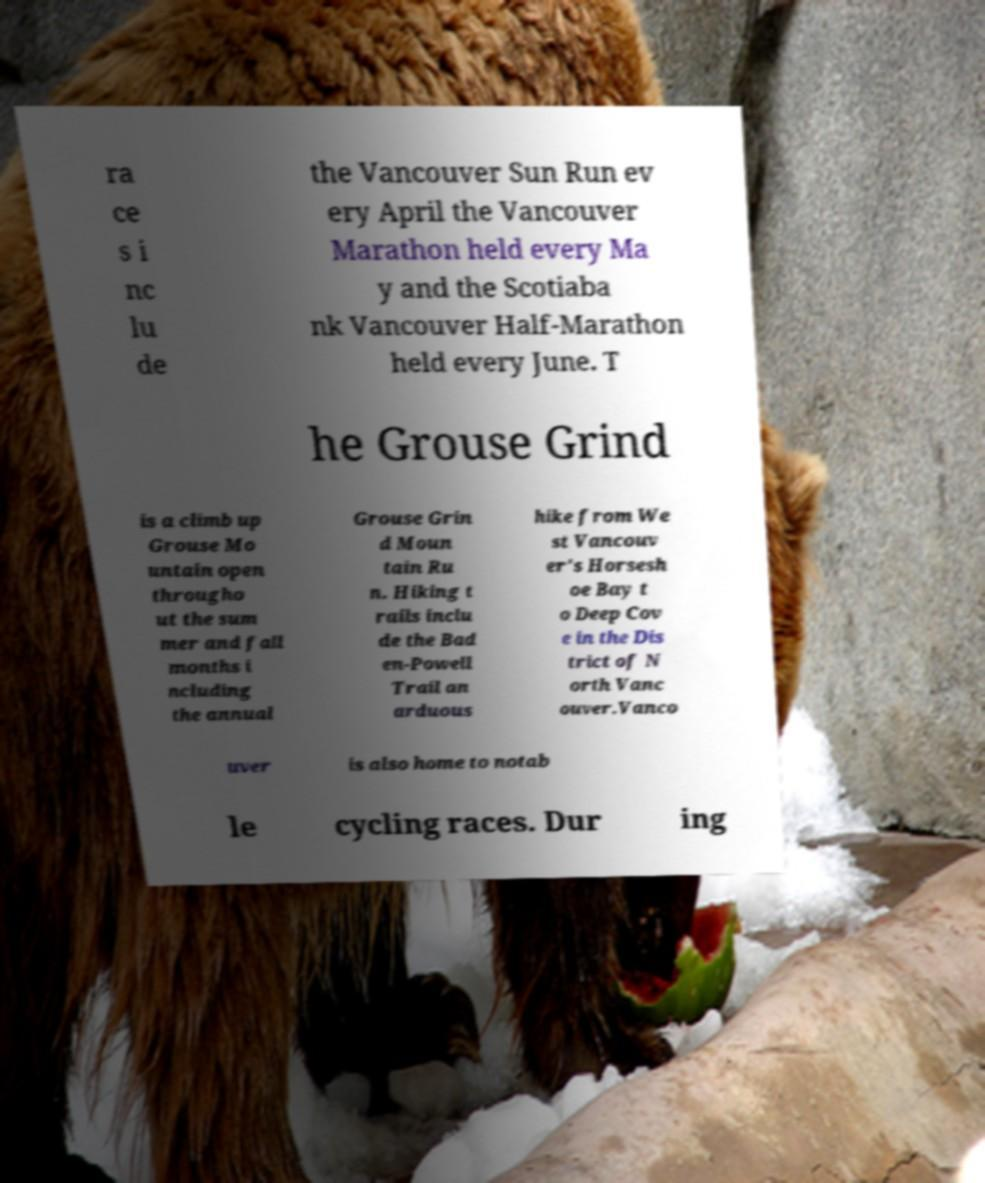Please identify and transcribe the text found in this image. ra ce s i nc lu de the Vancouver Sun Run ev ery April the Vancouver Marathon held every Ma y and the Scotiaba nk Vancouver Half-Marathon held every June. T he Grouse Grind is a climb up Grouse Mo untain open througho ut the sum mer and fall months i ncluding the annual Grouse Grin d Moun tain Ru n. Hiking t rails inclu de the Bad en-Powell Trail an arduous hike from We st Vancouv er's Horsesh oe Bay t o Deep Cov e in the Dis trict of N orth Vanc ouver.Vanco uver is also home to notab le cycling races. Dur ing 